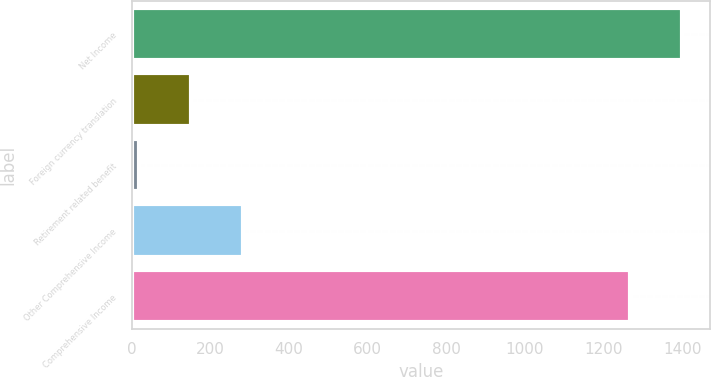<chart> <loc_0><loc_0><loc_500><loc_500><bar_chart><fcel>Net Income<fcel>Foreign currency translation<fcel>Retirement related benefit<fcel>Other Comprehensive Income<fcel>Comprehensive Income<nl><fcel>1400<fcel>150<fcel>18<fcel>282<fcel>1268<nl></chart> 